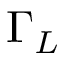<formula> <loc_0><loc_0><loc_500><loc_500>\Gamma _ { L }</formula> 